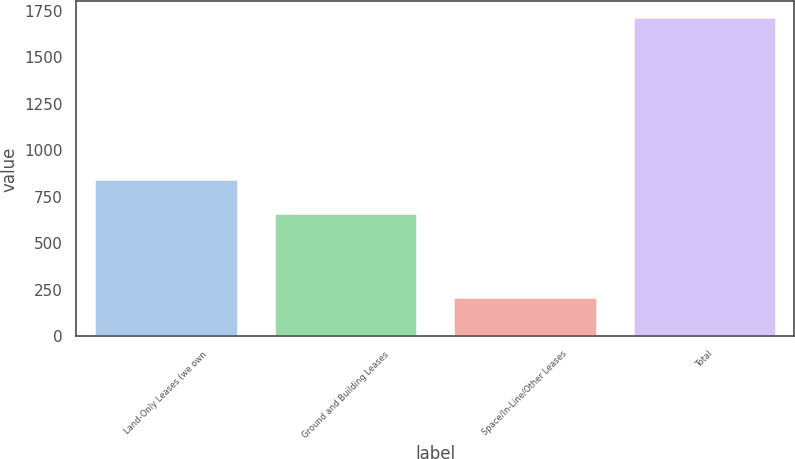<chart> <loc_0><loc_0><loc_500><loc_500><bar_chart><fcel>Land-Only Leases (we own<fcel>Ground and Building Leases<fcel>Space/In-Line/Other Leases<fcel>Total<nl><fcel>844<fcel>662<fcel>209<fcel>1715<nl></chart> 